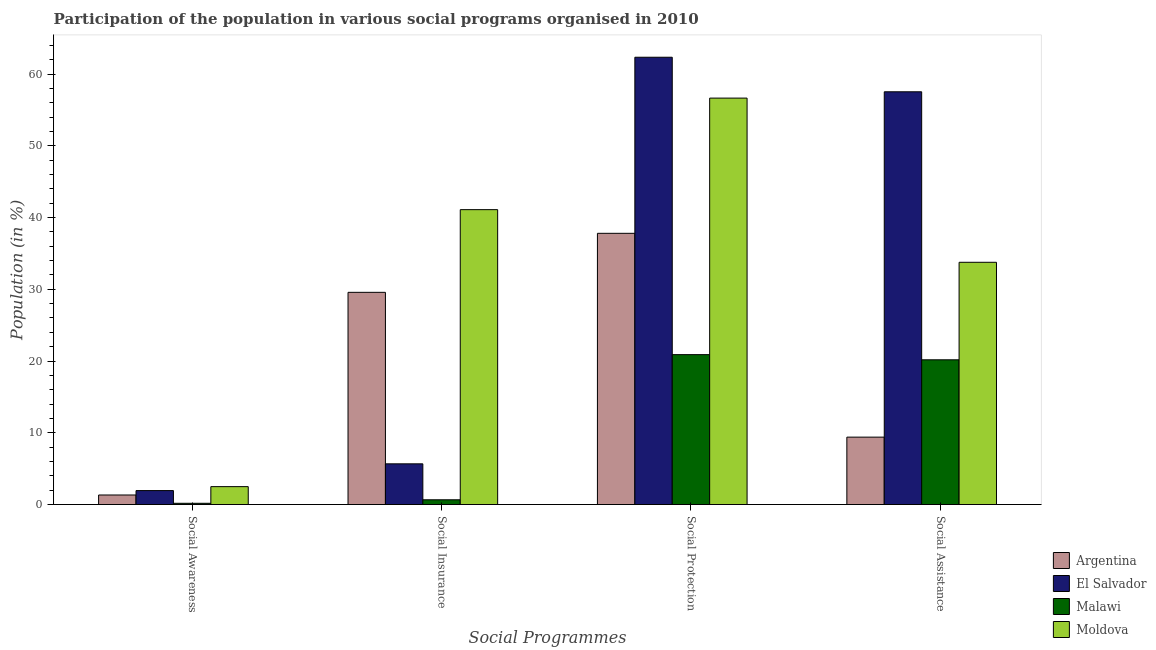How many different coloured bars are there?
Offer a terse response. 4. Are the number of bars per tick equal to the number of legend labels?
Give a very brief answer. Yes. How many bars are there on the 2nd tick from the left?
Keep it short and to the point. 4. What is the label of the 4th group of bars from the left?
Make the answer very short. Social Assistance. What is the participation of population in social awareness programs in Malawi?
Ensure brevity in your answer.  0.18. Across all countries, what is the maximum participation of population in social awareness programs?
Offer a terse response. 2.5. Across all countries, what is the minimum participation of population in social insurance programs?
Provide a short and direct response. 0.66. In which country was the participation of population in social protection programs maximum?
Provide a succinct answer. El Salvador. In which country was the participation of population in social protection programs minimum?
Offer a terse response. Malawi. What is the total participation of population in social protection programs in the graph?
Your response must be concise. 177.68. What is the difference between the participation of population in social assistance programs in Malawi and that in Moldova?
Your response must be concise. -13.59. What is the difference between the participation of population in social assistance programs in Argentina and the participation of population in social awareness programs in Moldova?
Your answer should be very brief. 6.9. What is the average participation of population in social awareness programs per country?
Ensure brevity in your answer.  1.49. What is the difference between the participation of population in social insurance programs and participation of population in social protection programs in Moldova?
Your response must be concise. -15.55. In how many countries, is the participation of population in social awareness programs greater than 54 %?
Your answer should be very brief. 0. What is the ratio of the participation of population in social awareness programs in Malawi to that in El Salvador?
Keep it short and to the point. 0.09. Is the participation of population in social awareness programs in El Salvador less than that in Malawi?
Your answer should be compact. No. Is the difference between the participation of population in social insurance programs in El Salvador and Argentina greater than the difference between the participation of population in social protection programs in El Salvador and Argentina?
Your response must be concise. No. What is the difference between the highest and the second highest participation of population in social assistance programs?
Your answer should be very brief. 23.76. What is the difference between the highest and the lowest participation of population in social awareness programs?
Provide a short and direct response. 2.32. What does the 1st bar from the left in Social Awareness represents?
Your response must be concise. Argentina. What does the 1st bar from the right in Social Assistance represents?
Offer a terse response. Moldova. How many bars are there?
Your response must be concise. 16. Does the graph contain any zero values?
Ensure brevity in your answer.  No. Does the graph contain grids?
Give a very brief answer. No. Where does the legend appear in the graph?
Provide a succinct answer. Bottom right. How many legend labels are there?
Make the answer very short. 4. What is the title of the graph?
Keep it short and to the point. Participation of the population in various social programs organised in 2010. Does "Georgia" appear as one of the legend labels in the graph?
Your response must be concise. No. What is the label or title of the X-axis?
Keep it short and to the point. Social Programmes. What is the Population (in %) in Argentina in Social Awareness?
Offer a terse response. 1.33. What is the Population (in %) of El Salvador in Social Awareness?
Provide a short and direct response. 1.95. What is the Population (in %) of Malawi in Social Awareness?
Give a very brief answer. 0.18. What is the Population (in %) in Moldova in Social Awareness?
Keep it short and to the point. 2.5. What is the Population (in %) of Argentina in Social Insurance?
Offer a terse response. 29.58. What is the Population (in %) of El Salvador in Social Insurance?
Provide a succinct answer. 5.67. What is the Population (in %) of Malawi in Social Insurance?
Provide a short and direct response. 0.66. What is the Population (in %) in Moldova in Social Insurance?
Your response must be concise. 41.1. What is the Population (in %) in Argentina in Social Protection?
Your answer should be compact. 37.8. What is the Population (in %) of El Salvador in Social Protection?
Provide a short and direct response. 62.34. What is the Population (in %) of Malawi in Social Protection?
Make the answer very short. 20.89. What is the Population (in %) of Moldova in Social Protection?
Keep it short and to the point. 56.65. What is the Population (in %) in Argentina in Social Assistance?
Offer a very short reply. 9.39. What is the Population (in %) of El Salvador in Social Assistance?
Offer a very short reply. 57.53. What is the Population (in %) in Malawi in Social Assistance?
Provide a succinct answer. 20.17. What is the Population (in %) in Moldova in Social Assistance?
Offer a terse response. 33.76. Across all Social Programmes, what is the maximum Population (in %) in Argentina?
Your answer should be very brief. 37.8. Across all Social Programmes, what is the maximum Population (in %) in El Salvador?
Your answer should be very brief. 62.34. Across all Social Programmes, what is the maximum Population (in %) in Malawi?
Your response must be concise. 20.89. Across all Social Programmes, what is the maximum Population (in %) in Moldova?
Provide a succinct answer. 56.65. Across all Social Programmes, what is the minimum Population (in %) of Argentina?
Offer a very short reply. 1.33. Across all Social Programmes, what is the minimum Population (in %) of El Salvador?
Offer a very short reply. 1.95. Across all Social Programmes, what is the minimum Population (in %) of Malawi?
Keep it short and to the point. 0.18. Across all Social Programmes, what is the minimum Population (in %) of Moldova?
Provide a succinct answer. 2.5. What is the total Population (in %) of Argentina in the graph?
Give a very brief answer. 78.1. What is the total Population (in %) of El Salvador in the graph?
Your answer should be compact. 127.48. What is the total Population (in %) in Malawi in the graph?
Provide a short and direct response. 41.9. What is the total Population (in %) in Moldova in the graph?
Your response must be concise. 134. What is the difference between the Population (in %) in Argentina in Social Awareness and that in Social Insurance?
Ensure brevity in your answer.  -28.24. What is the difference between the Population (in %) in El Salvador in Social Awareness and that in Social Insurance?
Offer a terse response. -3.73. What is the difference between the Population (in %) in Malawi in Social Awareness and that in Social Insurance?
Give a very brief answer. -0.49. What is the difference between the Population (in %) of Moldova in Social Awareness and that in Social Insurance?
Give a very brief answer. -38.6. What is the difference between the Population (in %) in Argentina in Social Awareness and that in Social Protection?
Your response must be concise. -36.47. What is the difference between the Population (in %) of El Salvador in Social Awareness and that in Social Protection?
Offer a terse response. -60.39. What is the difference between the Population (in %) in Malawi in Social Awareness and that in Social Protection?
Your answer should be very brief. -20.72. What is the difference between the Population (in %) of Moldova in Social Awareness and that in Social Protection?
Your answer should be compact. -54.15. What is the difference between the Population (in %) in Argentina in Social Awareness and that in Social Assistance?
Ensure brevity in your answer.  -8.06. What is the difference between the Population (in %) of El Salvador in Social Awareness and that in Social Assistance?
Your answer should be very brief. -55.58. What is the difference between the Population (in %) in Malawi in Social Awareness and that in Social Assistance?
Give a very brief answer. -20. What is the difference between the Population (in %) in Moldova in Social Awareness and that in Social Assistance?
Ensure brevity in your answer.  -31.27. What is the difference between the Population (in %) in Argentina in Social Insurance and that in Social Protection?
Make the answer very short. -8.23. What is the difference between the Population (in %) in El Salvador in Social Insurance and that in Social Protection?
Give a very brief answer. -56.67. What is the difference between the Population (in %) in Malawi in Social Insurance and that in Social Protection?
Give a very brief answer. -20.23. What is the difference between the Population (in %) in Moldova in Social Insurance and that in Social Protection?
Your answer should be compact. -15.55. What is the difference between the Population (in %) in Argentina in Social Insurance and that in Social Assistance?
Make the answer very short. 20.18. What is the difference between the Population (in %) of El Salvador in Social Insurance and that in Social Assistance?
Your answer should be very brief. -51.85. What is the difference between the Population (in %) of Malawi in Social Insurance and that in Social Assistance?
Make the answer very short. -19.51. What is the difference between the Population (in %) in Moldova in Social Insurance and that in Social Assistance?
Offer a terse response. 7.33. What is the difference between the Population (in %) of Argentina in Social Protection and that in Social Assistance?
Your answer should be very brief. 28.41. What is the difference between the Population (in %) in El Salvador in Social Protection and that in Social Assistance?
Offer a very short reply. 4.82. What is the difference between the Population (in %) of Malawi in Social Protection and that in Social Assistance?
Provide a succinct answer. 0.72. What is the difference between the Population (in %) of Moldova in Social Protection and that in Social Assistance?
Ensure brevity in your answer.  22.88. What is the difference between the Population (in %) in Argentina in Social Awareness and the Population (in %) in El Salvador in Social Insurance?
Ensure brevity in your answer.  -4.34. What is the difference between the Population (in %) in Argentina in Social Awareness and the Population (in %) in Malawi in Social Insurance?
Keep it short and to the point. 0.67. What is the difference between the Population (in %) of Argentina in Social Awareness and the Population (in %) of Moldova in Social Insurance?
Give a very brief answer. -39.77. What is the difference between the Population (in %) of El Salvador in Social Awareness and the Population (in %) of Malawi in Social Insurance?
Offer a terse response. 1.28. What is the difference between the Population (in %) of El Salvador in Social Awareness and the Population (in %) of Moldova in Social Insurance?
Give a very brief answer. -39.15. What is the difference between the Population (in %) in Malawi in Social Awareness and the Population (in %) in Moldova in Social Insurance?
Provide a short and direct response. -40.92. What is the difference between the Population (in %) of Argentina in Social Awareness and the Population (in %) of El Salvador in Social Protection?
Offer a very short reply. -61.01. What is the difference between the Population (in %) in Argentina in Social Awareness and the Population (in %) in Malawi in Social Protection?
Provide a short and direct response. -19.56. What is the difference between the Population (in %) of Argentina in Social Awareness and the Population (in %) of Moldova in Social Protection?
Your answer should be very brief. -55.31. What is the difference between the Population (in %) of El Salvador in Social Awareness and the Population (in %) of Malawi in Social Protection?
Give a very brief answer. -18.95. What is the difference between the Population (in %) of El Salvador in Social Awareness and the Population (in %) of Moldova in Social Protection?
Give a very brief answer. -54.7. What is the difference between the Population (in %) in Malawi in Social Awareness and the Population (in %) in Moldova in Social Protection?
Make the answer very short. -56.47. What is the difference between the Population (in %) of Argentina in Social Awareness and the Population (in %) of El Salvador in Social Assistance?
Your response must be concise. -56.19. What is the difference between the Population (in %) in Argentina in Social Awareness and the Population (in %) in Malawi in Social Assistance?
Offer a terse response. -18.84. What is the difference between the Population (in %) in Argentina in Social Awareness and the Population (in %) in Moldova in Social Assistance?
Your answer should be compact. -32.43. What is the difference between the Population (in %) in El Salvador in Social Awareness and the Population (in %) in Malawi in Social Assistance?
Offer a terse response. -18.23. What is the difference between the Population (in %) in El Salvador in Social Awareness and the Population (in %) in Moldova in Social Assistance?
Offer a terse response. -31.82. What is the difference between the Population (in %) in Malawi in Social Awareness and the Population (in %) in Moldova in Social Assistance?
Provide a succinct answer. -33.59. What is the difference between the Population (in %) of Argentina in Social Insurance and the Population (in %) of El Salvador in Social Protection?
Your answer should be compact. -32.77. What is the difference between the Population (in %) in Argentina in Social Insurance and the Population (in %) in Malawi in Social Protection?
Keep it short and to the point. 8.68. What is the difference between the Population (in %) in Argentina in Social Insurance and the Population (in %) in Moldova in Social Protection?
Offer a very short reply. -27.07. What is the difference between the Population (in %) in El Salvador in Social Insurance and the Population (in %) in Malawi in Social Protection?
Provide a succinct answer. -15.22. What is the difference between the Population (in %) in El Salvador in Social Insurance and the Population (in %) in Moldova in Social Protection?
Offer a terse response. -50.97. What is the difference between the Population (in %) of Malawi in Social Insurance and the Population (in %) of Moldova in Social Protection?
Your answer should be very brief. -55.98. What is the difference between the Population (in %) in Argentina in Social Insurance and the Population (in %) in El Salvador in Social Assistance?
Provide a short and direct response. -27.95. What is the difference between the Population (in %) of Argentina in Social Insurance and the Population (in %) of Malawi in Social Assistance?
Provide a short and direct response. 9.4. What is the difference between the Population (in %) of Argentina in Social Insurance and the Population (in %) of Moldova in Social Assistance?
Your response must be concise. -4.19. What is the difference between the Population (in %) in El Salvador in Social Insurance and the Population (in %) in Malawi in Social Assistance?
Give a very brief answer. -14.5. What is the difference between the Population (in %) in El Salvador in Social Insurance and the Population (in %) in Moldova in Social Assistance?
Provide a succinct answer. -28.09. What is the difference between the Population (in %) in Malawi in Social Insurance and the Population (in %) in Moldova in Social Assistance?
Keep it short and to the point. -33.1. What is the difference between the Population (in %) in Argentina in Social Protection and the Population (in %) in El Salvador in Social Assistance?
Keep it short and to the point. -19.72. What is the difference between the Population (in %) of Argentina in Social Protection and the Population (in %) of Malawi in Social Assistance?
Provide a short and direct response. 17.63. What is the difference between the Population (in %) of Argentina in Social Protection and the Population (in %) of Moldova in Social Assistance?
Make the answer very short. 4.04. What is the difference between the Population (in %) in El Salvador in Social Protection and the Population (in %) in Malawi in Social Assistance?
Provide a short and direct response. 42.17. What is the difference between the Population (in %) in El Salvador in Social Protection and the Population (in %) in Moldova in Social Assistance?
Provide a succinct answer. 28.58. What is the difference between the Population (in %) of Malawi in Social Protection and the Population (in %) of Moldova in Social Assistance?
Provide a short and direct response. -12.87. What is the average Population (in %) in Argentina per Social Programmes?
Provide a short and direct response. 19.53. What is the average Population (in %) of El Salvador per Social Programmes?
Provide a succinct answer. 31.87. What is the average Population (in %) in Malawi per Social Programmes?
Your answer should be compact. 10.48. What is the average Population (in %) of Moldova per Social Programmes?
Your response must be concise. 33.5. What is the difference between the Population (in %) of Argentina and Population (in %) of El Salvador in Social Awareness?
Ensure brevity in your answer.  -0.61. What is the difference between the Population (in %) of Argentina and Population (in %) of Malawi in Social Awareness?
Offer a terse response. 1.16. What is the difference between the Population (in %) of Argentina and Population (in %) of Moldova in Social Awareness?
Offer a terse response. -1.16. What is the difference between the Population (in %) in El Salvador and Population (in %) in Malawi in Social Awareness?
Your response must be concise. 1.77. What is the difference between the Population (in %) of El Salvador and Population (in %) of Moldova in Social Awareness?
Make the answer very short. -0.55. What is the difference between the Population (in %) in Malawi and Population (in %) in Moldova in Social Awareness?
Ensure brevity in your answer.  -2.32. What is the difference between the Population (in %) in Argentina and Population (in %) in El Salvador in Social Insurance?
Make the answer very short. 23.9. What is the difference between the Population (in %) of Argentina and Population (in %) of Malawi in Social Insurance?
Your answer should be compact. 28.91. What is the difference between the Population (in %) in Argentina and Population (in %) in Moldova in Social Insurance?
Ensure brevity in your answer.  -11.52. What is the difference between the Population (in %) in El Salvador and Population (in %) in Malawi in Social Insurance?
Provide a short and direct response. 5.01. What is the difference between the Population (in %) of El Salvador and Population (in %) of Moldova in Social Insurance?
Make the answer very short. -35.42. What is the difference between the Population (in %) of Malawi and Population (in %) of Moldova in Social Insurance?
Offer a terse response. -40.44. What is the difference between the Population (in %) of Argentina and Population (in %) of El Salvador in Social Protection?
Provide a short and direct response. -24.54. What is the difference between the Population (in %) in Argentina and Population (in %) in Malawi in Social Protection?
Ensure brevity in your answer.  16.91. What is the difference between the Population (in %) of Argentina and Population (in %) of Moldova in Social Protection?
Keep it short and to the point. -18.85. What is the difference between the Population (in %) in El Salvador and Population (in %) in Malawi in Social Protection?
Your answer should be compact. 41.45. What is the difference between the Population (in %) in El Salvador and Population (in %) in Moldova in Social Protection?
Provide a succinct answer. 5.69. What is the difference between the Population (in %) in Malawi and Population (in %) in Moldova in Social Protection?
Your answer should be very brief. -35.75. What is the difference between the Population (in %) in Argentina and Population (in %) in El Salvador in Social Assistance?
Provide a short and direct response. -48.13. What is the difference between the Population (in %) of Argentina and Population (in %) of Malawi in Social Assistance?
Provide a succinct answer. -10.78. What is the difference between the Population (in %) in Argentina and Population (in %) in Moldova in Social Assistance?
Your answer should be very brief. -24.37. What is the difference between the Population (in %) in El Salvador and Population (in %) in Malawi in Social Assistance?
Your answer should be very brief. 37.35. What is the difference between the Population (in %) of El Salvador and Population (in %) of Moldova in Social Assistance?
Provide a short and direct response. 23.76. What is the difference between the Population (in %) in Malawi and Population (in %) in Moldova in Social Assistance?
Offer a very short reply. -13.59. What is the ratio of the Population (in %) of Argentina in Social Awareness to that in Social Insurance?
Offer a very short reply. 0.04. What is the ratio of the Population (in %) in El Salvador in Social Awareness to that in Social Insurance?
Your answer should be very brief. 0.34. What is the ratio of the Population (in %) of Malawi in Social Awareness to that in Social Insurance?
Provide a succinct answer. 0.26. What is the ratio of the Population (in %) of Moldova in Social Awareness to that in Social Insurance?
Your response must be concise. 0.06. What is the ratio of the Population (in %) in Argentina in Social Awareness to that in Social Protection?
Provide a succinct answer. 0.04. What is the ratio of the Population (in %) of El Salvador in Social Awareness to that in Social Protection?
Provide a short and direct response. 0.03. What is the ratio of the Population (in %) of Malawi in Social Awareness to that in Social Protection?
Keep it short and to the point. 0.01. What is the ratio of the Population (in %) in Moldova in Social Awareness to that in Social Protection?
Ensure brevity in your answer.  0.04. What is the ratio of the Population (in %) of Argentina in Social Awareness to that in Social Assistance?
Give a very brief answer. 0.14. What is the ratio of the Population (in %) in El Salvador in Social Awareness to that in Social Assistance?
Provide a succinct answer. 0.03. What is the ratio of the Population (in %) of Malawi in Social Awareness to that in Social Assistance?
Provide a short and direct response. 0.01. What is the ratio of the Population (in %) of Moldova in Social Awareness to that in Social Assistance?
Keep it short and to the point. 0.07. What is the ratio of the Population (in %) of Argentina in Social Insurance to that in Social Protection?
Provide a short and direct response. 0.78. What is the ratio of the Population (in %) of El Salvador in Social Insurance to that in Social Protection?
Provide a short and direct response. 0.09. What is the ratio of the Population (in %) of Malawi in Social Insurance to that in Social Protection?
Ensure brevity in your answer.  0.03. What is the ratio of the Population (in %) of Moldova in Social Insurance to that in Social Protection?
Provide a succinct answer. 0.73. What is the ratio of the Population (in %) of Argentina in Social Insurance to that in Social Assistance?
Ensure brevity in your answer.  3.15. What is the ratio of the Population (in %) of El Salvador in Social Insurance to that in Social Assistance?
Your answer should be compact. 0.1. What is the ratio of the Population (in %) of Malawi in Social Insurance to that in Social Assistance?
Offer a very short reply. 0.03. What is the ratio of the Population (in %) of Moldova in Social Insurance to that in Social Assistance?
Give a very brief answer. 1.22. What is the ratio of the Population (in %) in Argentina in Social Protection to that in Social Assistance?
Offer a terse response. 4.02. What is the ratio of the Population (in %) in El Salvador in Social Protection to that in Social Assistance?
Offer a terse response. 1.08. What is the ratio of the Population (in %) in Malawi in Social Protection to that in Social Assistance?
Your answer should be very brief. 1.04. What is the ratio of the Population (in %) of Moldova in Social Protection to that in Social Assistance?
Your response must be concise. 1.68. What is the difference between the highest and the second highest Population (in %) of Argentina?
Ensure brevity in your answer.  8.23. What is the difference between the highest and the second highest Population (in %) in El Salvador?
Keep it short and to the point. 4.82. What is the difference between the highest and the second highest Population (in %) of Malawi?
Your answer should be very brief. 0.72. What is the difference between the highest and the second highest Population (in %) in Moldova?
Offer a very short reply. 15.55. What is the difference between the highest and the lowest Population (in %) of Argentina?
Offer a terse response. 36.47. What is the difference between the highest and the lowest Population (in %) of El Salvador?
Your answer should be very brief. 60.39. What is the difference between the highest and the lowest Population (in %) in Malawi?
Keep it short and to the point. 20.72. What is the difference between the highest and the lowest Population (in %) of Moldova?
Give a very brief answer. 54.15. 